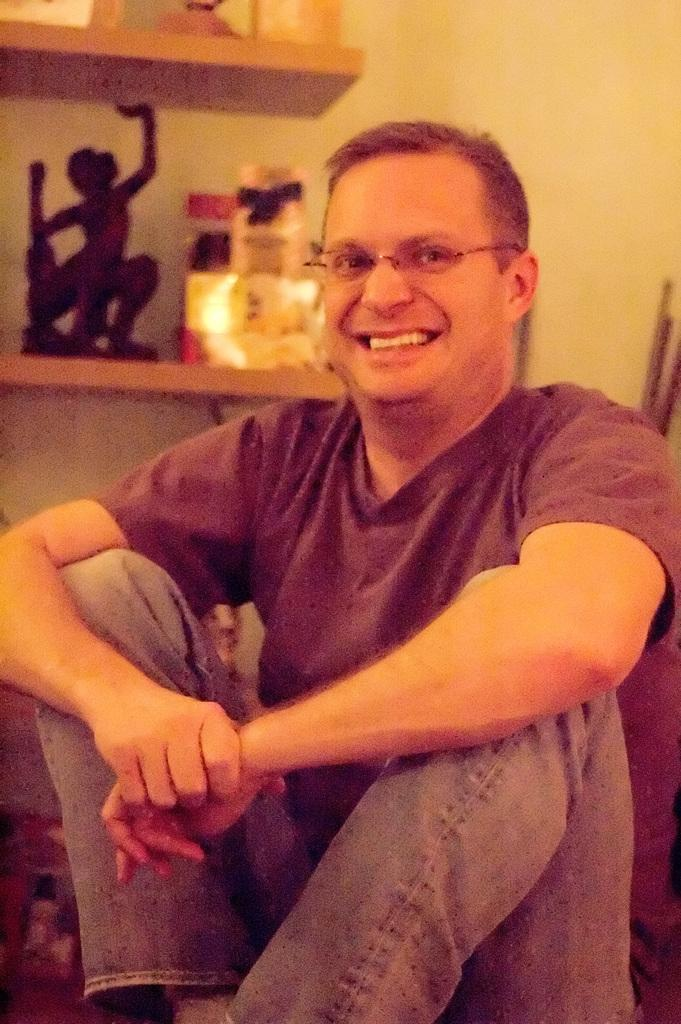What is the person in the image doing? The person is sitting on the floor in the image. What can be seen in the background of the image? There are shelves visible in the background of the image. What is on the shelves? There are things arranged on the shelves. What effect does the thunder have on the rabbit in the image? There is no rabbit or thunder present in the image. 